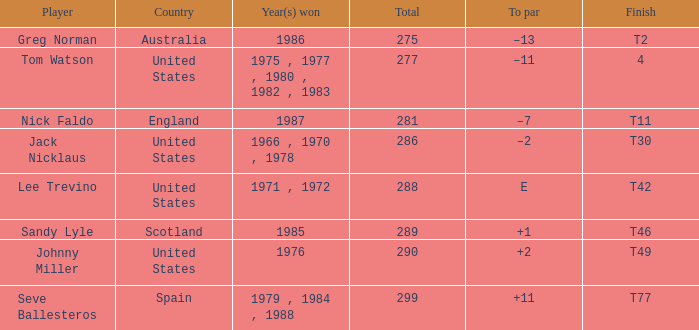What's the finish for the total 288? T42. 